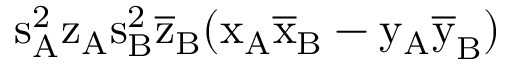<formula> <loc_0><loc_0><loc_500><loc_500>s _ { A } ^ { 2 } \mathrm { z _ { A } \mathrm { s _ { B } ^ { 2 } \mathrm { \overline { z } _ { B } ( \mathrm { x _ { A } \mathrm { \overline { x } _ { B } - \mathrm { y _ { A } \mathrm { \overline { y } _ { B } ) } } } } } } }</formula> 